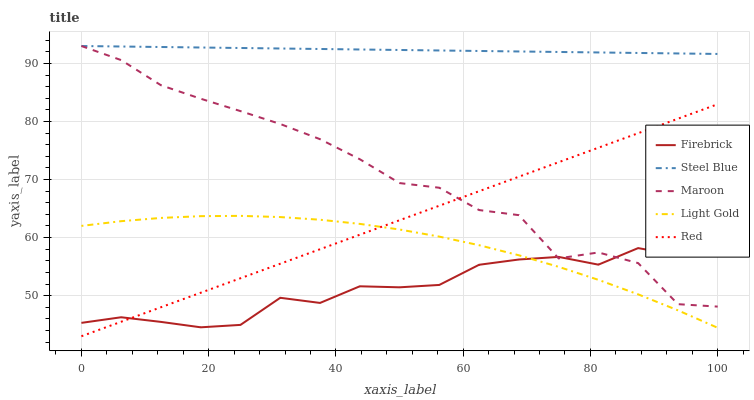Does Light Gold have the minimum area under the curve?
Answer yes or no. No. Does Light Gold have the maximum area under the curve?
Answer yes or no. No. Is Firebrick the smoothest?
Answer yes or no. No. Is Firebrick the roughest?
Answer yes or no. No. Does Firebrick have the lowest value?
Answer yes or no. No. Does Light Gold have the highest value?
Answer yes or no. No. Is Red less than Steel Blue?
Answer yes or no. Yes. Is Steel Blue greater than Firebrick?
Answer yes or no. Yes. Does Red intersect Steel Blue?
Answer yes or no. No. 